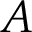Convert formula to latex. <formula><loc_0><loc_0><loc_500><loc_500>A</formula> 